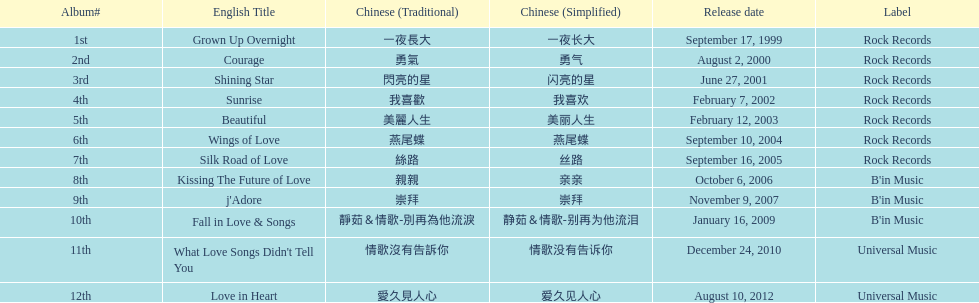In the table, which song appears at the beginning? Grown Up Overnight. 